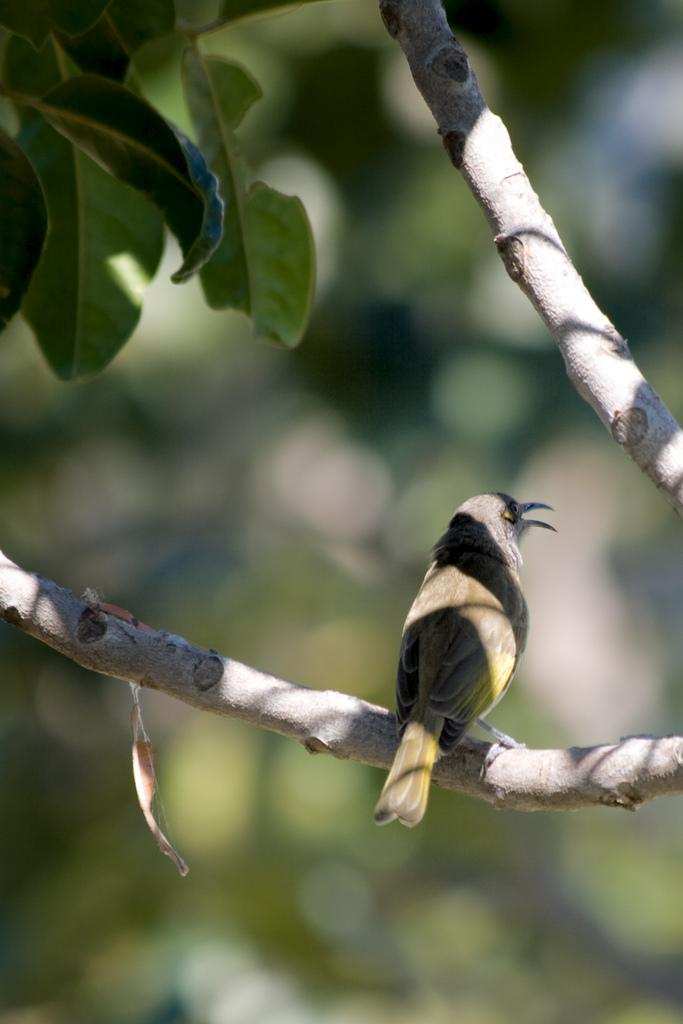What type of animal can be seen in the image? There is a bird in the image. What color is the bird? The bird is brown in color. Where is the bird located in the image? The bird is on the branch of a tree. What can be seen in the background of the image? There are leaves visible in the background of the image. What type of key is the bird holding in the image? There is no key present in the image; it features a brown bird on the branch of a tree. 